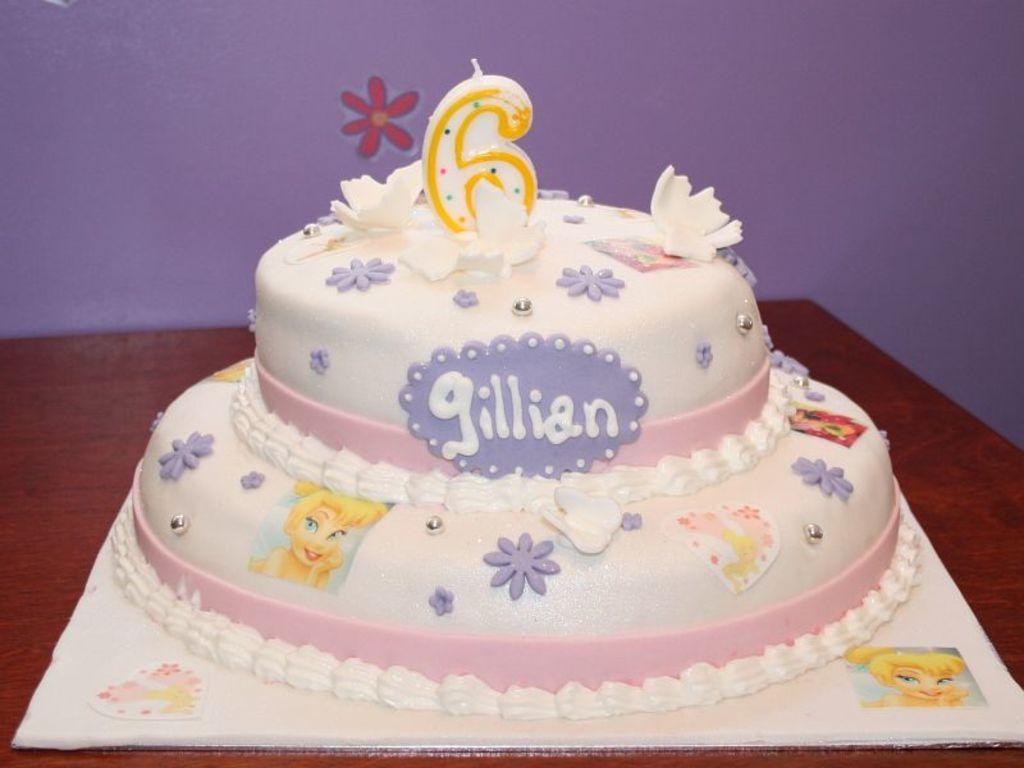Describe this image in one or two sentences. In the foreground of this picture we can see a wooden table on the top of which a cake containing text and the depictions of flowers and the depiction of a person and a candle, is placed. In the foreground there is an object on which we can see the depiction of a person and the depiction of some objects. In the background we can see the wall and the depiction of a flower on the wall. 